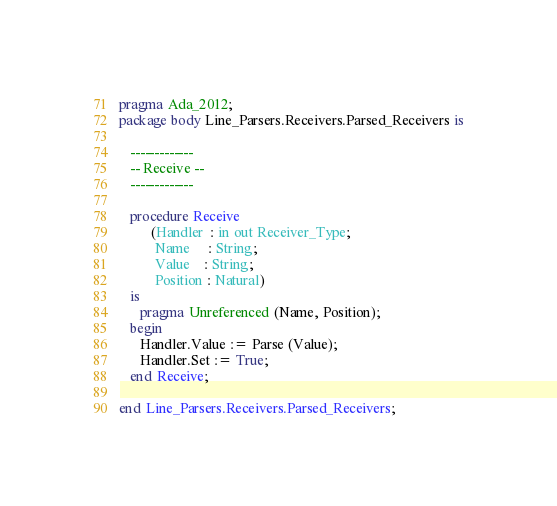Convert code to text. <code><loc_0><loc_0><loc_500><loc_500><_Ada_>pragma Ada_2012;
package body Line_Parsers.Receivers.Parsed_Receivers is

   -------------
   -- Receive --
   -------------

   procedure Receive
         (Handler  : in out Receiver_Type;
          Name     : String;
          Value    : String;
          Position : Natural)
   is
      pragma Unreferenced (Name, Position);
   begin
      Handler.Value := Parse (Value);
      Handler.Set := True;
   end Receive;

end Line_Parsers.Receivers.Parsed_Receivers;
</code> 